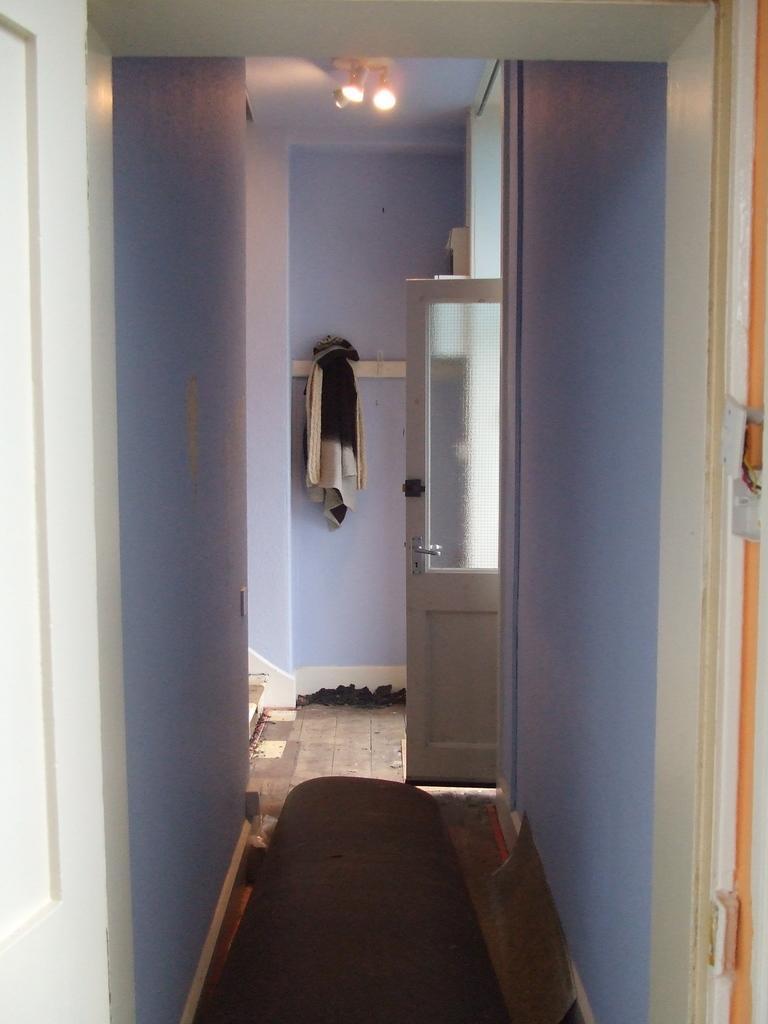Please provide a concise description of this image. This is the inside picture of the building. In this image there is a door. There is a wall. There is a towel on the rod. At the bottom of the image there is a mat and a few other objects. On top of the image there are lights. 